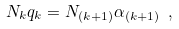<formula> <loc_0><loc_0><loc_500><loc_500>N _ { k } q _ { k } = N _ { ( k + 1 ) } \alpha _ { ( k + 1 ) } \ ,</formula> 